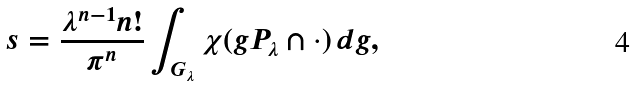<formula> <loc_0><loc_0><loc_500><loc_500>s = \frac { \lambda ^ { n - 1 } n ! } { \pi ^ { n } } \int _ { G _ { \lambda } } \chi ( g P _ { \lambda } \cap \cdot ) \, d g ,</formula> 